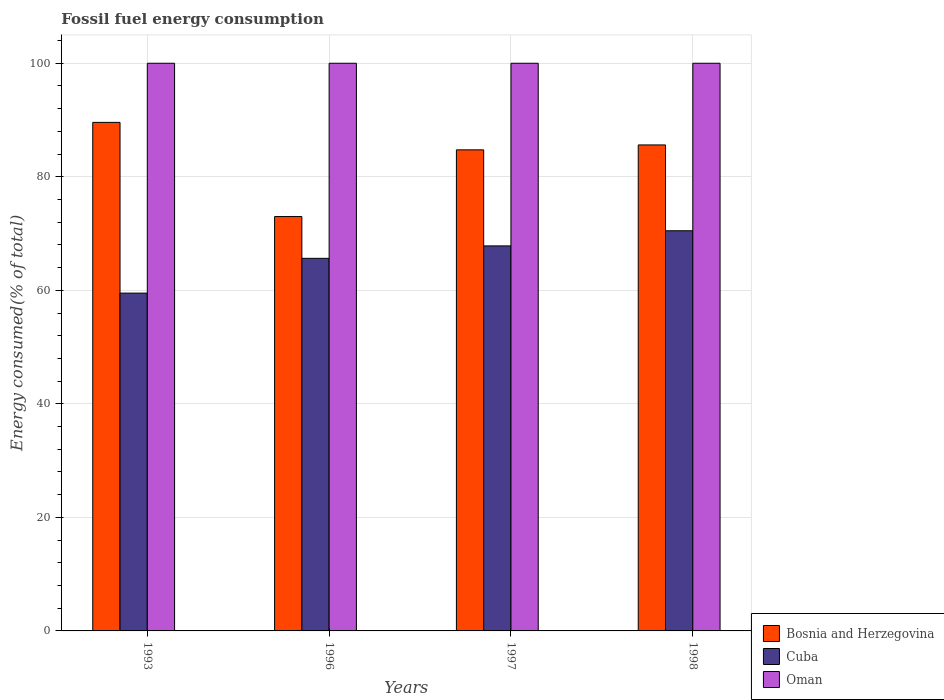How many different coloured bars are there?
Your answer should be very brief. 3. How many groups of bars are there?
Give a very brief answer. 4. Are the number of bars per tick equal to the number of legend labels?
Give a very brief answer. Yes. Are the number of bars on each tick of the X-axis equal?
Offer a terse response. Yes. How many bars are there on the 2nd tick from the left?
Your response must be concise. 3. What is the label of the 4th group of bars from the left?
Offer a terse response. 1998. In how many cases, is the number of bars for a given year not equal to the number of legend labels?
Your answer should be compact. 0. Across all years, what is the maximum percentage of energy consumed in Bosnia and Herzegovina?
Your answer should be very brief. 89.58. Across all years, what is the minimum percentage of energy consumed in Bosnia and Herzegovina?
Offer a terse response. 72.99. In which year was the percentage of energy consumed in Oman minimum?
Your answer should be very brief. 1998. What is the total percentage of energy consumed in Bosnia and Herzegovina in the graph?
Your answer should be compact. 332.94. What is the difference between the percentage of energy consumed in Oman in 1993 and that in 1998?
Give a very brief answer. 4.416370720150553e-5. What is the difference between the percentage of energy consumed in Oman in 1997 and the percentage of energy consumed in Cuba in 1998?
Your response must be concise. 29.51. What is the average percentage of energy consumed in Bosnia and Herzegovina per year?
Your answer should be compact. 83.23. In the year 1998, what is the difference between the percentage of energy consumed in Oman and percentage of energy consumed in Bosnia and Herzegovina?
Offer a very short reply. 14.39. In how many years, is the percentage of energy consumed in Oman greater than 68 %?
Offer a terse response. 4. What is the ratio of the percentage of energy consumed in Bosnia and Herzegovina in 1997 to that in 1998?
Your answer should be compact. 0.99. Is the percentage of energy consumed in Cuba in 1997 less than that in 1998?
Your response must be concise. Yes. What is the difference between the highest and the second highest percentage of energy consumed in Cuba?
Give a very brief answer. 2.67. What is the difference between the highest and the lowest percentage of energy consumed in Cuba?
Your answer should be very brief. 10.98. In how many years, is the percentage of energy consumed in Oman greater than the average percentage of energy consumed in Oman taken over all years?
Keep it short and to the point. 3. What does the 2nd bar from the left in 1998 represents?
Offer a very short reply. Cuba. What does the 1st bar from the right in 1996 represents?
Ensure brevity in your answer.  Oman. How many bars are there?
Give a very brief answer. 12. Are the values on the major ticks of Y-axis written in scientific E-notation?
Keep it short and to the point. No. Does the graph contain any zero values?
Provide a short and direct response. No. Where does the legend appear in the graph?
Offer a terse response. Bottom right. How many legend labels are there?
Provide a short and direct response. 3. What is the title of the graph?
Ensure brevity in your answer.  Fossil fuel energy consumption. What is the label or title of the X-axis?
Provide a short and direct response. Years. What is the label or title of the Y-axis?
Give a very brief answer. Energy consumed(% of total). What is the Energy consumed(% of total) of Bosnia and Herzegovina in 1993?
Your answer should be very brief. 89.58. What is the Energy consumed(% of total) in Cuba in 1993?
Provide a succinct answer. 59.51. What is the Energy consumed(% of total) of Bosnia and Herzegovina in 1996?
Keep it short and to the point. 72.99. What is the Energy consumed(% of total) in Cuba in 1996?
Make the answer very short. 65.63. What is the Energy consumed(% of total) in Oman in 1996?
Your answer should be compact. 100. What is the Energy consumed(% of total) of Bosnia and Herzegovina in 1997?
Give a very brief answer. 84.75. What is the Energy consumed(% of total) in Cuba in 1997?
Provide a succinct answer. 67.83. What is the Energy consumed(% of total) of Oman in 1997?
Your response must be concise. 100. What is the Energy consumed(% of total) of Bosnia and Herzegovina in 1998?
Offer a very short reply. 85.61. What is the Energy consumed(% of total) of Cuba in 1998?
Give a very brief answer. 70.49. What is the Energy consumed(% of total) in Oman in 1998?
Provide a short and direct response. 100. Across all years, what is the maximum Energy consumed(% of total) of Bosnia and Herzegovina?
Provide a short and direct response. 89.58. Across all years, what is the maximum Energy consumed(% of total) of Cuba?
Your answer should be very brief. 70.49. Across all years, what is the maximum Energy consumed(% of total) of Oman?
Your response must be concise. 100. Across all years, what is the minimum Energy consumed(% of total) of Bosnia and Herzegovina?
Ensure brevity in your answer.  72.99. Across all years, what is the minimum Energy consumed(% of total) in Cuba?
Offer a very short reply. 59.51. Across all years, what is the minimum Energy consumed(% of total) of Oman?
Your answer should be very brief. 100. What is the total Energy consumed(% of total) of Bosnia and Herzegovina in the graph?
Your response must be concise. 332.94. What is the total Energy consumed(% of total) of Cuba in the graph?
Offer a very short reply. 263.46. What is the difference between the Energy consumed(% of total) in Bosnia and Herzegovina in 1993 and that in 1996?
Provide a short and direct response. 16.59. What is the difference between the Energy consumed(% of total) of Cuba in 1993 and that in 1996?
Provide a short and direct response. -6.12. What is the difference between the Energy consumed(% of total) of Bosnia and Herzegovina in 1993 and that in 1997?
Ensure brevity in your answer.  4.84. What is the difference between the Energy consumed(% of total) in Cuba in 1993 and that in 1997?
Provide a succinct answer. -8.31. What is the difference between the Energy consumed(% of total) of Bosnia and Herzegovina in 1993 and that in 1998?
Your response must be concise. 3.97. What is the difference between the Energy consumed(% of total) of Cuba in 1993 and that in 1998?
Your answer should be compact. -10.98. What is the difference between the Energy consumed(% of total) of Oman in 1993 and that in 1998?
Your response must be concise. 0. What is the difference between the Energy consumed(% of total) in Bosnia and Herzegovina in 1996 and that in 1997?
Make the answer very short. -11.75. What is the difference between the Energy consumed(% of total) in Cuba in 1996 and that in 1997?
Make the answer very short. -2.19. What is the difference between the Energy consumed(% of total) of Bosnia and Herzegovina in 1996 and that in 1998?
Ensure brevity in your answer.  -12.62. What is the difference between the Energy consumed(% of total) in Cuba in 1996 and that in 1998?
Provide a short and direct response. -4.86. What is the difference between the Energy consumed(% of total) in Bosnia and Herzegovina in 1997 and that in 1998?
Make the answer very short. -0.87. What is the difference between the Energy consumed(% of total) in Cuba in 1997 and that in 1998?
Offer a very short reply. -2.67. What is the difference between the Energy consumed(% of total) of Oman in 1997 and that in 1998?
Your answer should be compact. 0. What is the difference between the Energy consumed(% of total) in Bosnia and Herzegovina in 1993 and the Energy consumed(% of total) in Cuba in 1996?
Offer a very short reply. 23.95. What is the difference between the Energy consumed(% of total) in Bosnia and Herzegovina in 1993 and the Energy consumed(% of total) in Oman in 1996?
Keep it short and to the point. -10.42. What is the difference between the Energy consumed(% of total) of Cuba in 1993 and the Energy consumed(% of total) of Oman in 1996?
Provide a succinct answer. -40.49. What is the difference between the Energy consumed(% of total) in Bosnia and Herzegovina in 1993 and the Energy consumed(% of total) in Cuba in 1997?
Provide a short and direct response. 21.76. What is the difference between the Energy consumed(% of total) in Bosnia and Herzegovina in 1993 and the Energy consumed(% of total) in Oman in 1997?
Provide a short and direct response. -10.42. What is the difference between the Energy consumed(% of total) of Cuba in 1993 and the Energy consumed(% of total) of Oman in 1997?
Your response must be concise. -40.49. What is the difference between the Energy consumed(% of total) in Bosnia and Herzegovina in 1993 and the Energy consumed(% of total) in Cuba in 1998?
Offer a terse response. 19.09. What is the difference between the Energy consumed(% of total) in Bosnia and Herzegovina in 1993 and the Energy consumed(% of total) in Oman in 1998?
Your answer should be very brief. -10.42. What is the difference between the Energy consumed(% of total) of Cuba in 1993 and the Energy consumed(% of total) of Oman in 1998?
Your answer should be very brief. -40.49. What is the difference between the Energy consumed(% of total) of Bosnia and Herzegovina in 1996 and the Energy consumed(% of total) of Cuba in 1997?
Your answer should be compact. 5.17. What is the difference between the Energy consumed(% of total) in Bosnia and Herzegovina in 1996 and the Energy consumed(% of total) in Oman in 1997?
Keep it short and to the point. -27.01. What is the difference between the Energy consumed(% of total) in Cuba in 1996 and the Energy consumed(% of total) in Oman in 1997?
Your answer should be very brief. -34.37. What is the difference between the Energy consumed(% of total) of Bosnia and Herzegovina in 1996 and the Energy consumed(% of total) of Cuba in 1998?
Provide a short and direct response. 2.5. What is the difference between the Energy consumed(% of total) in Bosnia and Herzegovina in 1996 and the Energy consumed(% of total) in Oman in 1998?
Your answer should be compact. -27.01. What is the difference between the Energy consumed(% of total) in Cuba in 1996 and the Energy consumed(% of total) in Oman in 1998?
Provide a short and direct response. -34.37. What is the difference between the Energy consumed(% of total) in Bosnia and Herzegovina in 1997 and the Energy consumed(% of total) in Cuba in 1998?
Provide a succinct answer. 14.25. What is the difference between the Energy consumed(% of total) of Bosnia and Herzegovina in 1997 and the Energy consumed(% of total) of Oman in 1998?
Make the answer very short. -15.25. What is the difference between the Energy consumed(% of total) in Cuba in 1997 and the Energy consumed(% of total) in Oman in 1998?
Keep it short and to the point. -32.17. What is the average Energy consumed(% of total) of Bosnia and Herzegovina per year?
Offer a very short reply. 83.23. What is the average Energy consumed(% of total) in Cuba per year?
Offer a very short reply. 65.87. What is the average Energy consumed(% of total) in Oman per year?
Offer a very short reply. 100. In the year 1993, what is the difference between the Energy consumed(% of total) of Bosnia and Herzegovina and Energy consumed(% of total) of Cuba?
Keep it short and to the point. 30.07. In the year 1993, what is the difference between the Energy consumed(% of total) in Bosnia and Herzegovina and Energy consumed(% of total) in Oman?
Keep it short and to the point. -10.42. In the year 1993, what is the difference between the Energy consumed(% of total) in Cuba and Energy consumed(% of total) in Oman?
Make the answer very short. -40.49. In the year 1996, what is the difference between the Energy consumed(% of total) of Bosnia and Herzegovina and Energy consumed(% of total) of Cuba?
Ensure brevity in your answer.  7.36. In the year 1996, what is the difference between the Energy consumed(% of total) of Bosnia and Herzegovina and Energy consumed(% of total) of Oman?
Provide a short and direct response. -27.01. In the year 1996, what is the difference between the Energy consumed(% of total) of Cuba and Energy consumed(% of total) of Oman?
Your answer should be very brief. -34.37. In the year 1997, what is the difference between the Energy consumed(% of total) of Bosnia and Herzegovina and Energy consumed(% of total) of Cuba?
Keep it short and to the point. 16.92. In the year 1997, what is the difference between the Energy consumed(% of total) of Bosnia and Herzegovina and Energy consumed(% of total) of Oman?
Offer a very short reply. -15.25. In the year 1997, what is the difference between the Energy consumed(% of total) of Cuba and Energy consumed(% of total) of Oman?
Offer a terse response. -32.17. In the year 1998, what is the difference between the Energy consumed(% of total) of Bosnia and Herzegovina and Energy consumed(% of total) of Cuba?
Your response must be concise. 15.12. In the year 1998, what is the difference between the Energy consumed(% of total) of Bosnia and Herzegovina and Energy consumed(% of total) of Oman?
Provide a succinct answer. -14.39. In the year 1998, what is the difference between the Energy consumed(% of total) of Cuba and Energy consumed(% of total) of Oman?
Your response must be concise. -29.51. What is the ratio of the Energy consumed(% of total) in Bosnia and Herzegovina in 1993 to that in 1996?
Ensure brevity in your answer.  1.23. What is the ratio of the Energy consumed(% of total) in Cuba in 1993 to that in 1996?
Your response must be concise. 0.91. What is the ratio of the Energy consumed(% of total) of Oman in 1993 to that in 1996?
Your answer should be very brief. 1. What is the ratio of the Energy consumed(% of total) of Bosnia and Herzegovina in 1993 to that in 1997?
Ensure brevity in your answer.  1.06. What is the ratio of the Energy consumed(% of total) in Cuba in 1993 to that in 1997?
Your answer should be very brief. 0.88. What is the ratio of the Energy consumed(% of total) in Bosnia and Herzegovina in 1993 to that in 1998?
Offer a very short reply. 1.05. What is the ratio of the Energy consumed(% of total) in Cuba in 1993 to that in 1998?
Your response must be concise. 0.84. What is the ratio of the Energy consumed(% of total) of Bosnia and Herzegovina in 1996 to that in 1997?
Offer a terse response. 0.86. What is the ratio of the Energy consumed(% of total) of Bosnia and Herzegovina in 1996 to that in 1998?
Provide a short and direct response. 0.85. What is the ratio of the Energy consumed(% of total) in Cuba in 1996 to that in 1998?
Your answer should be very brief. 0.93. What is the ratio of the Energy consumed(% of total) in Oman in 1996 to that in 1998?
Offer a very short reply. 1. What is the ratio of the Energy consumed(% of total) in Bosnia and Herzegovina in 1997 to that in 1998?
Offer a very short reply. 0.99. What is the ratio of the Energy consumed(% of total) in Cuba in 1997 to that in 1998?
Your answer should be very brief. 0.96. What is the difference between the highest and the second highest Energy consumed(% of total) in Bosnia and Herzegovina?
Your response must be concise. 3.97. What is the difference between the highest and the second highest Energy consumed(% of total) of Cuba?
Provide a succinct answer. 2.67. What is the difference between the highest and the second highest Energy consumed(% of total) in Oman?
Make the answer very short. 0. What is the difference between the highest and the lowest Energy consumed(% of total) of Bosnia and Herzegovina?
Your answer should be compact. 16.59. What is the difference between the highest and the lowest Energy consumed(% of total) in Cuba?
Keep it short and to the point. 10.98. What is the difference between the highest and the lowest Energy consumed(% of total) in Oman?
Make the answer very short. 0. 